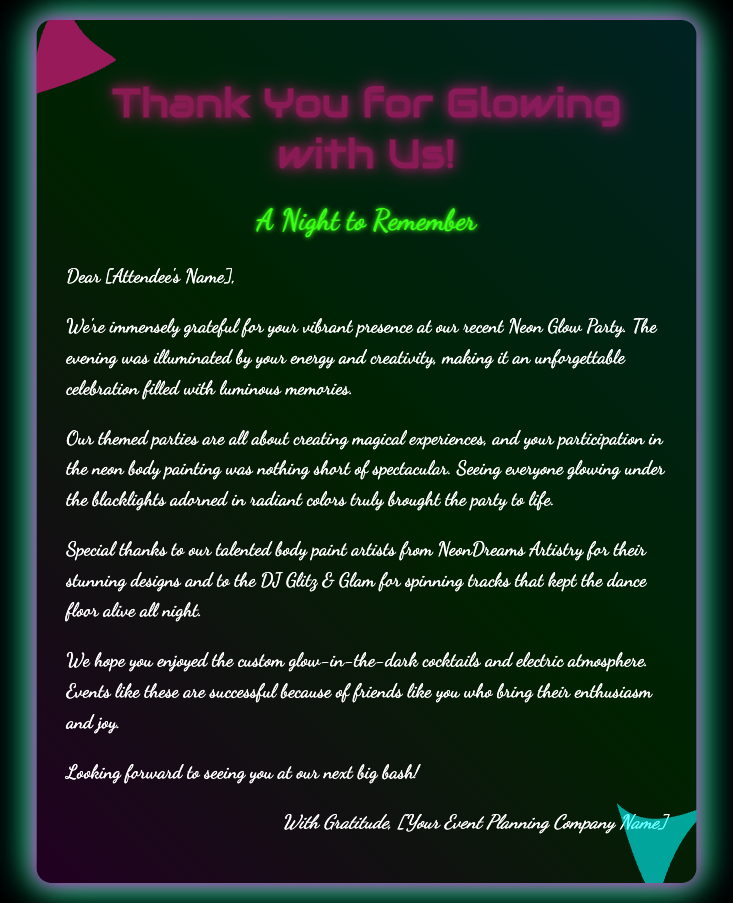What is the title of the card? The title of the card is prominently displayed at the top, expressing gratitude.
Answer: Thank You for Glowing with Us! Who are the body paint artists mentioned? The body paint artists who contributed to the event are specifically acknowledged in the document.
Answer: NeonDreams Artistry What did attendees enjoy under the blacklights? The document highlights a specific activity that attendees participated in, which was illuminated.
Answer: Neon body painting Which phrase describes the event atmosphere? The card describes the overall atmosphere created during the party with a specific term for the ambiance.
Answer: Electric atmosphere What color is the text-shadow for the main title? The specific color code for the text-shadow of the title is included in the document.
Answer: #ff1493 How many splash elements are in the design? The card features a specific number of unique paint splash elements incorporated in the design.
Answer: Two What type of parties does the event planning company specialize in? The document mentions the focus of the events organized by the company, showing their thematic nature.
Answer: Themed parties What does the signature express at the end of the card? The closing of the card conveys a specific sentiment from the sender to the recipient.
Answer: Gratitude 